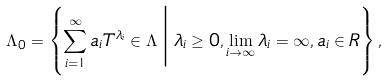Convert formula to latex. <formula><loc_0><loc_0><loc_500><loc_500>\Lambda _ { 0 } = \left \{ \sum _ { i = 1 } ^ { \infty } a _ { i } T ^ { \lambda _ { i } } \in \Lambda \, \Big | \, \lambda _ { i } \geq 0 , \lim _ { i \to \infty } \lambda _ { i } = \infty , a _ { i } \in R \right \} ,</formula> 